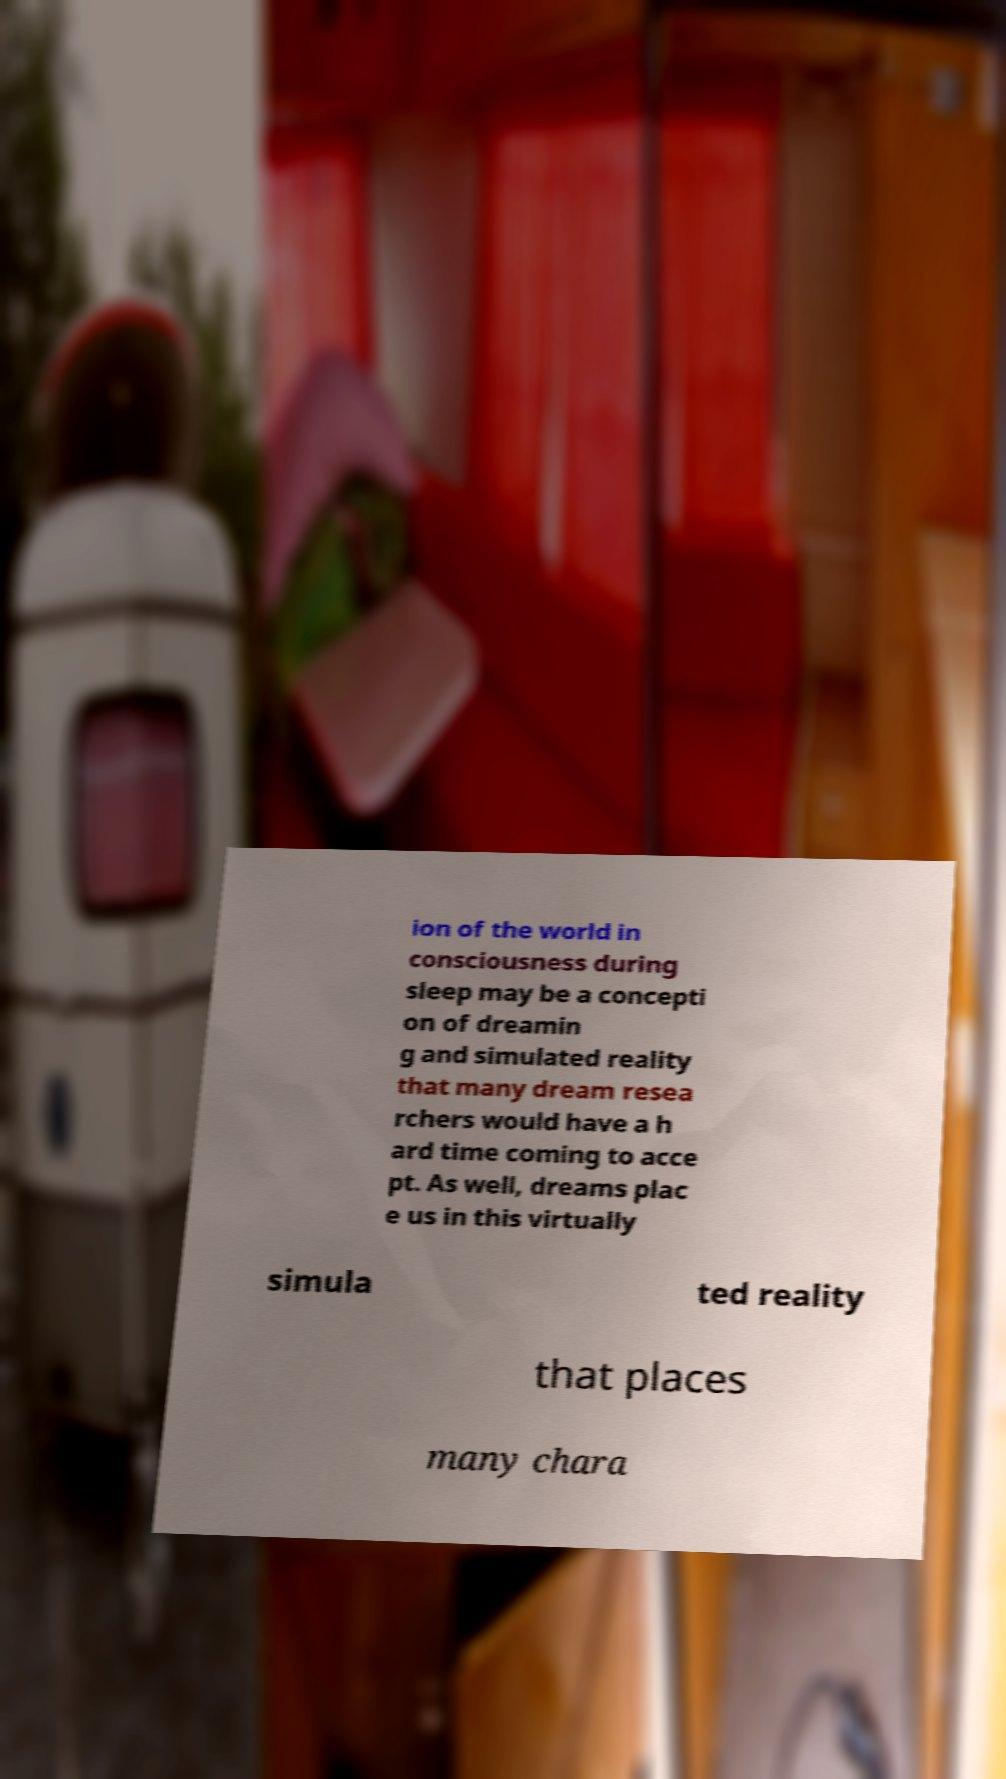Please identify and transcribe the text found in this image. ion of the world in consciousness during sleep may be a concepti on of dreamin g and simulated reality that many dream resea rchers would have a h ard time coming to acce pt. As well, dreams plac e us in this virtually simula ted reality that places many chara 